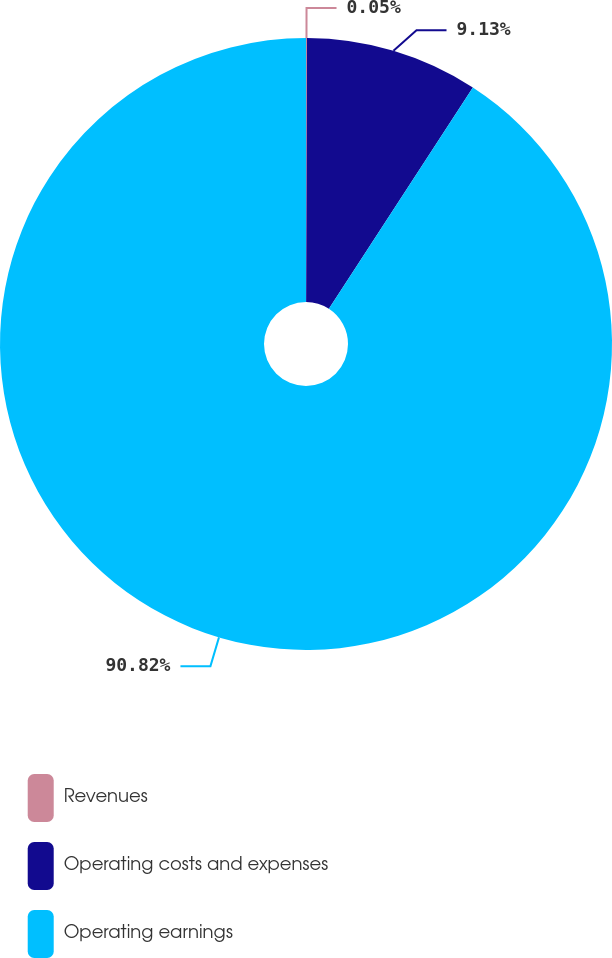Convert chart. <chart><loc_0><loc_0><loc_500><loc_500><pie_chart><fcel>Revenues<fcel>Operating costs and expenses<fcel>Operating earnings<nl><fcel>0.05%<fcel>9.13%<fcel>90.83%<nl></chart> 